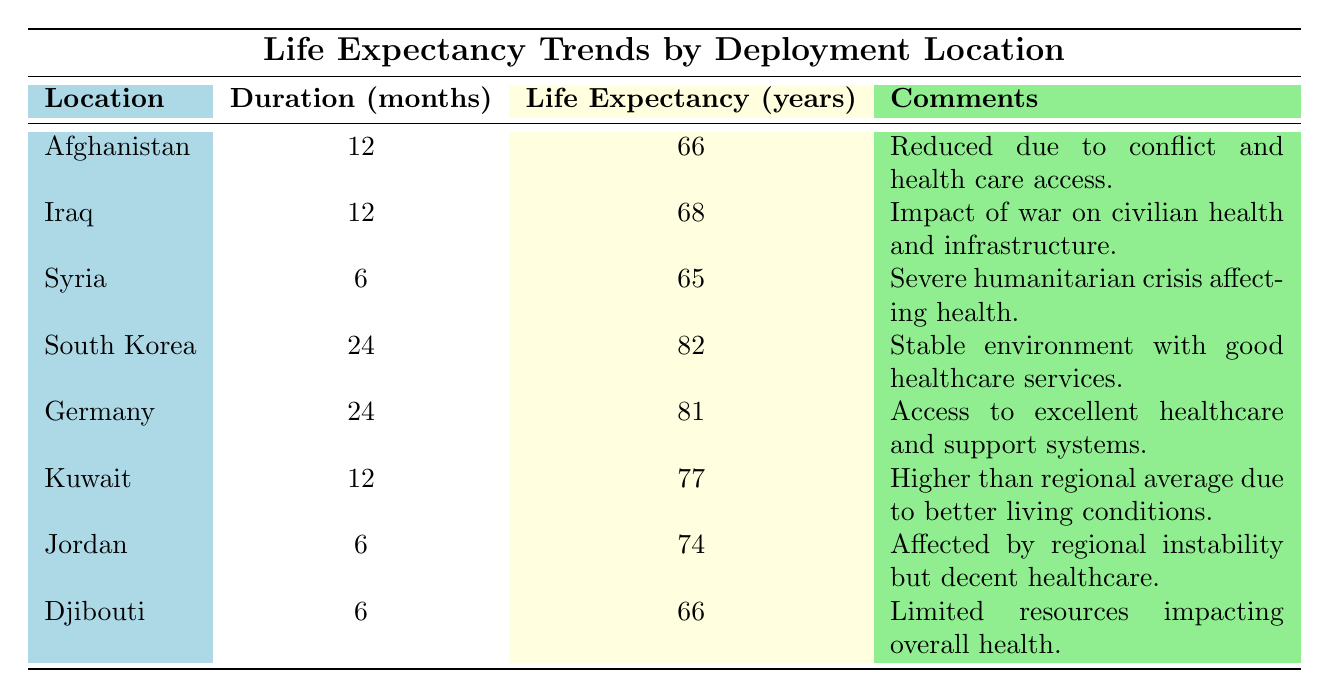What is the average life expectancy for a deployment duration of 12 months? The life expectancy for 12-month deployments includes Afghanistan (66 years), Iraq (68 years), and Kuwait (77 years). To find the average, sum these values: 66 + 68 + 77 = 211. There are 3 data points, so divide by 3: 211/3 = approximately 70.33.
Answer: Approximately 70.33 years Which deployment location has the highest average life expectancy? The locations with their life expectancies are: Afghanistan (66 years), Iraq (68 years), Syria (65 years), South Korea (82 years), Germany (81 years), Kuwait (77 years), Jordan (74 years), and Djibouti (66 years). The highest value is South Korea at 82 years.
Answer: South Korea Is the average life expectancy in Iraq greater than that in Afghanistan? Iraq has an average life expectancy of 68 years, while Afghanistan has 66 years. Since 68 is greater than 66, the statement is true.
Answer: Yes How much greater is the life expectancy in Germany compared to Syria? Germany's life expectancy is 81 years and Syria's is 65 years. To find the difference, subtract: 81 - 65 = 16 years.
Answer: 16 years Does any deployment location show a life expectancy of 74 years? The only deployment location with an average life expectancy of 74 years is Jordan. Therefore, the statement is true.
Answer: Yes What factors contribute to the reduced life expectancy in Afghanistan? The table states that the life expectancy in Afghanistan is reduced due to conflict and healthcare access issues. This is the specific reason mentioned for its lower life expectancy.
Answer: Conflict and healthcare access issues If two countries have a deployment duration of 6 months, what is their average life expectancy? The countries with a 6-month duration are Syria (65 years), Jordan (74 years), and Djibouti (66 years). To calculate the average: (65 + 74 + 66) = 205, and dividing by 3 gives approximately 68.33.
Answer: Approximately 68.33 years Which has a longer deployment duration, South Korea or Kuwait? South Korea has a deployment duration of 24 months while Kuwait has 12 months. Since 24 is greater than 12, South Korea has a longer duration.
Answer: South Korea 